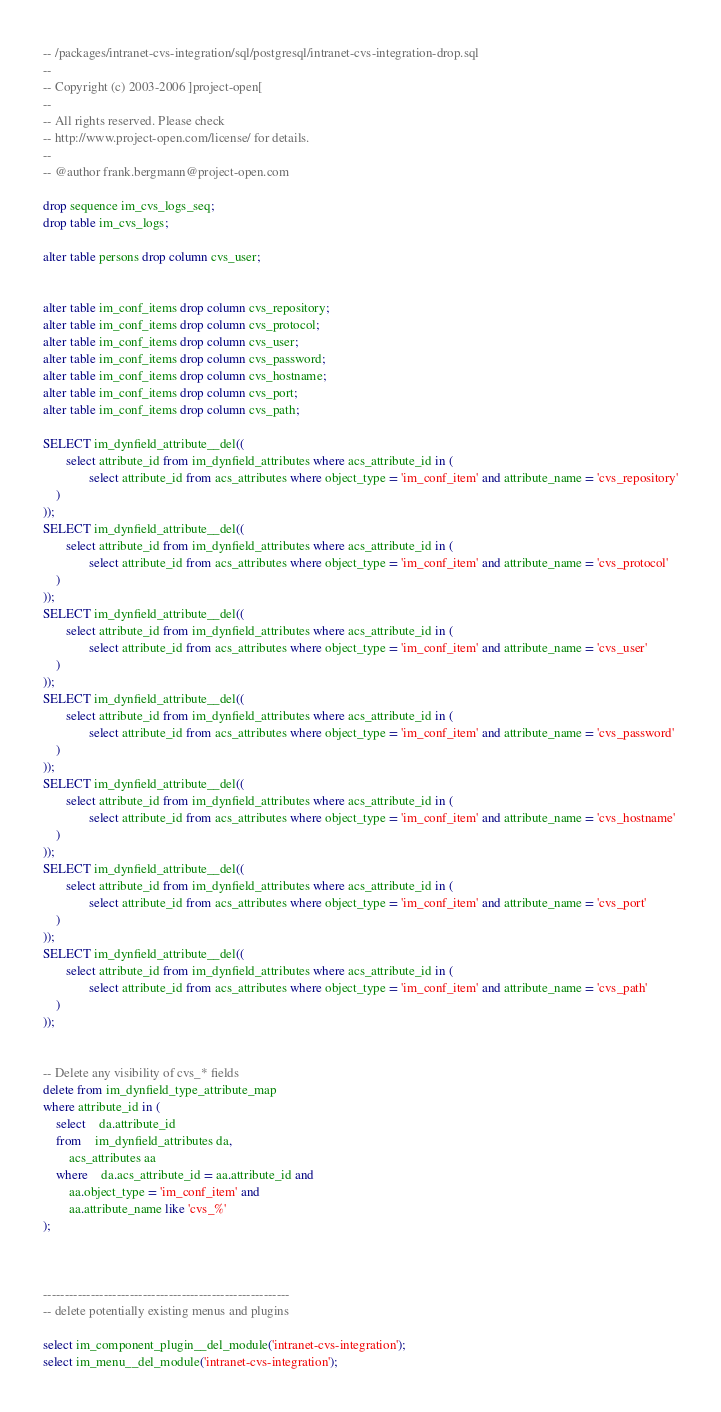<code> <loc_0><loc_0><loc_500><loc_500><_SQL_>-- /packages/intranet-cvs-integration/sql/postgresql/intranet-cvs-integration-drop.sql
--
-- Copyright (c) 2003-2006 ]project-open[
--
-- All rights reserved. Please check
-- http://www.project-open.com/license/ for details.
--
-- @author frank.bergmann@project-open.com

drop sequence im_cvs_logs_seq;
drop table im_cvs_logs;

alter table persons drop column cvs_user;


alter table im_conf_items drop column cvs_repository;
alter table im_conf_items drop column cvs_protocol;
alter table im_conf_items drop column cvs_user;
alter table im_conf_items drop column cvs_password;
alter table im_conf_items drop column cvs_hostname;
alter table im_conf_items drop column cvs_port;
alter table im_conf_items drop column cvs_path;

SELECT im_dynfield_attribute__del((
       select attribute_id from im_dynfield_attributes where acs_attribute_id in (
       	      select attribute_id from acs_attributes where object_type = 'im_conf_item' and attribute_name = 'cvs_repository'
	)
));
SELECT im_dynfield_attribute__del((
       select attribute_id from im_dynfield_attributes where acs_attribute_id in (
       	      select attribute_id from acs_attributes where object_type = 'im_conf_item' and attribute_name = 'cvs_protocol'
	)
));
SELECT im_dynfield_attribute__del((
       select attribute_id from im_dynfield_attributes where acs_attribute_id in (
       	      select attribute_id from acs_attributes where object_type = 'im_conf_item' and attribute_name = 'cvs_user'
	)
));
SELECT im_dynfield_attribute__del((
       select attribute_id from im_dynfield_attributes where acs_attribute_id in (
       	      select attribute_id from acs_attributes where object_type = 'im_conf_item' and attribute_name = 'cvs_password'
	)
));
SELECT im_dynfield_attribute__del((
       select attribute_id from im_dynfield_attributes where acs_attribute_id in (
       	      select attribute_id from acs_attributes where object_type = 'im_conf_item' and attribute_name = 'cvs_hostname'
	)
));
SELECT im_dynfield_attribute__del((
       select attribute_id from im_dynfield_attributes where acs_attribute_id in (
       	      select attribute_id from acs_attributes where object_type = 'im_conf_item' and attribute_name = 'cvs_port'
	)
));
SELECT im_dynfield_attribute__del((
       select attribute_id from im_dynfield_attributes where acs_attribute_id in (
       	      select attribute_id from acs_attributes where object_type = 'im_conf_item' and attribute_name = 'cvs_path'
	)
));


-- Delete any visibility of cvs_* fields
delete from im_dynfield_type_attribute_map
where attribute_id in (
	select	da.attribute_id
	from	im_dynfield_attributes da,
		acs_attributes aa
	where	da.acs_attribute_id = aa.attribute_id and
		aa.object_type = 'im_conf_item' and
		aa.attribute_name like 'cvs_%'
);



---------------------------------------------------------
-- delete potentially existing menus and plugins

select im_component_plugin__del_module('intranet-cvs-integration');
select im_menu__del_module('intranet-cvs-integration');



</code> 